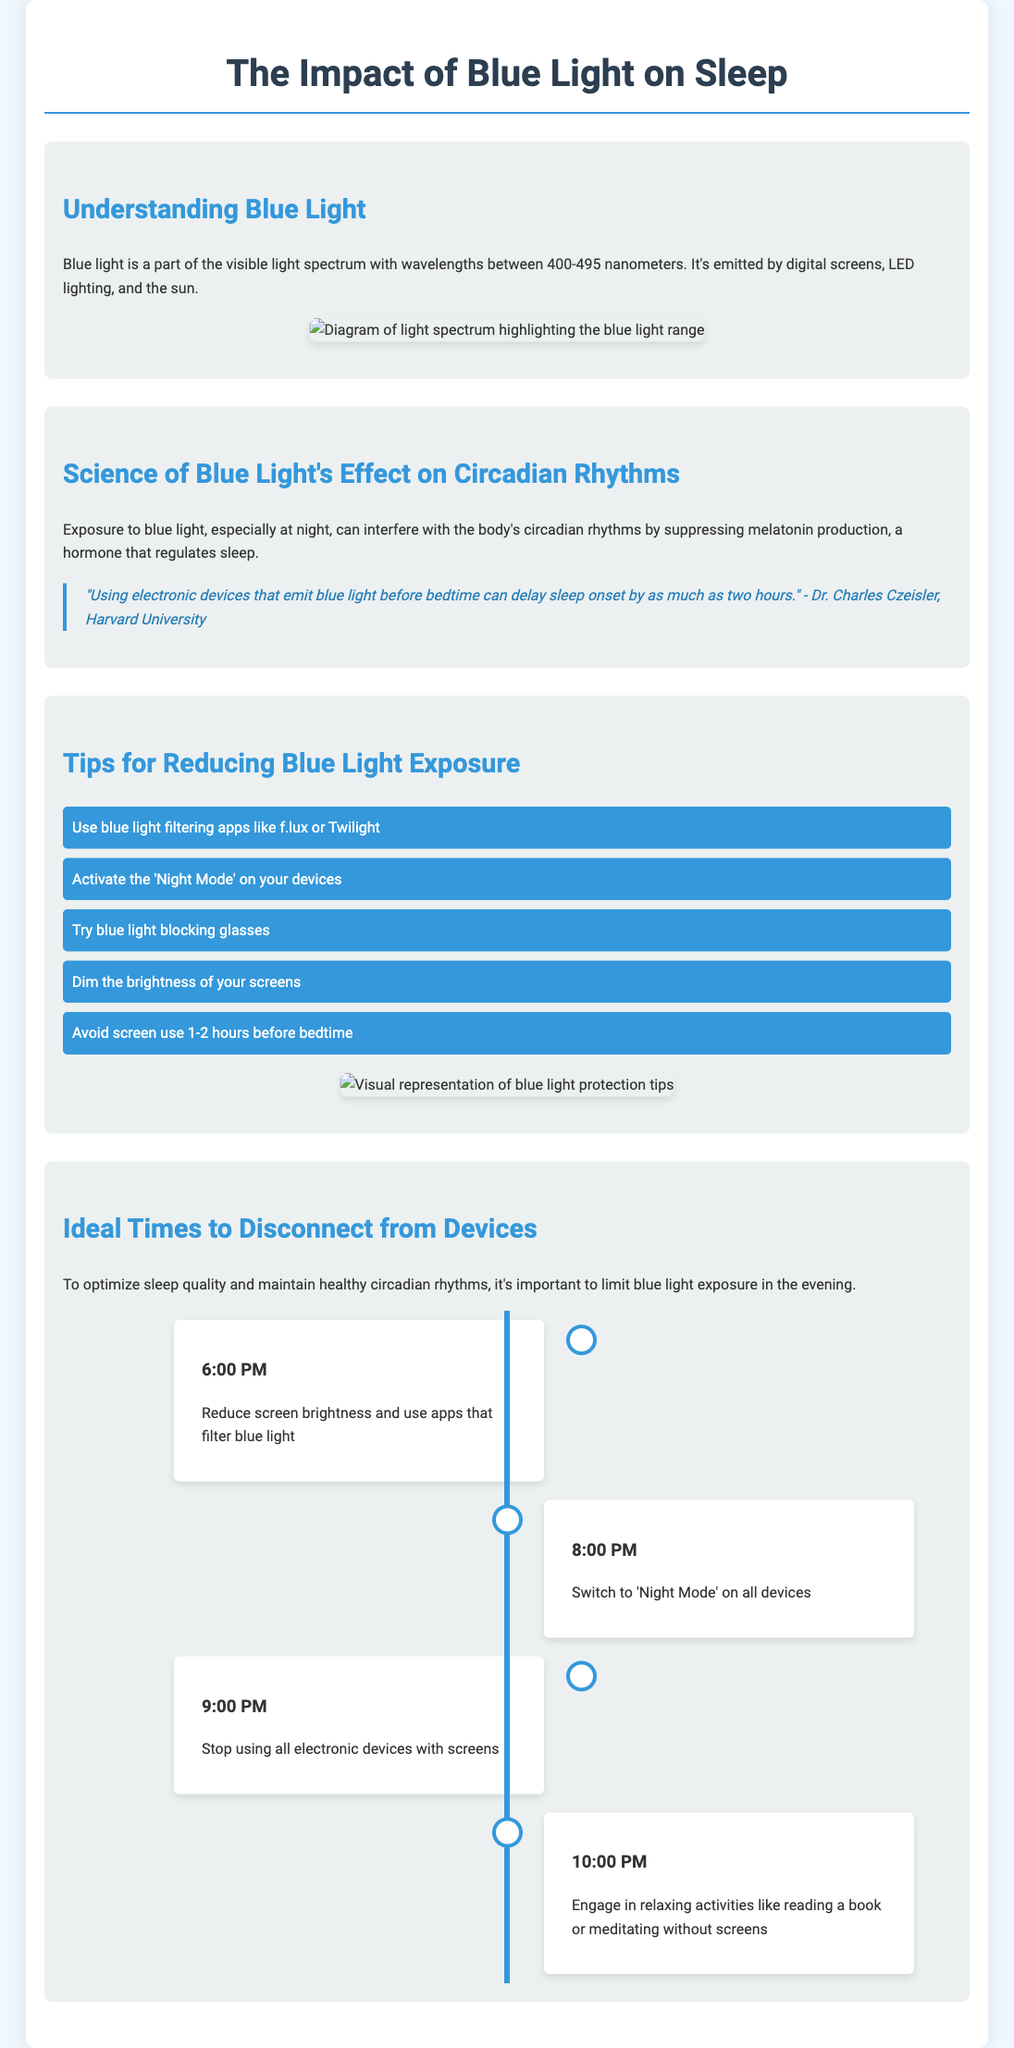What is blue light's wavelength range? Blue light is defined as having wavelengths between 400-495 nanometers, according to the document.
Answer: 400-495 nanometers Who stated that blue light can delay sleep onset? The quote from the document attributes the statement about blue light delaying sleep onset to Dr. Charles Czeisler from Harvard University.
Answer: Dr. Charles Czeisler What is one method to reduce blue light exposure? The document lists several methods, one of which is using blue light filtering apps like f.lux or Twilight.
Answer: Use blue light filtering apps At what time should you stop using electronic devices? The timeline in the infographic suggests stopping the use of electronic devices with screens at 9:00 PM.
Answer: 9:00 PM What activity can you engage in at 10:00 PM? The document recommends engaging in relaxing activities like reading a book or meditating without screens at 10:00 PM.
Answer: Reading a book or meditating What is the primary hormone affected by blue light exposure? The document indicates that blue light exposure can suppress melatonin production, which is the primary hormone regulated by circadian rhythms.
Answer: Melatonin 